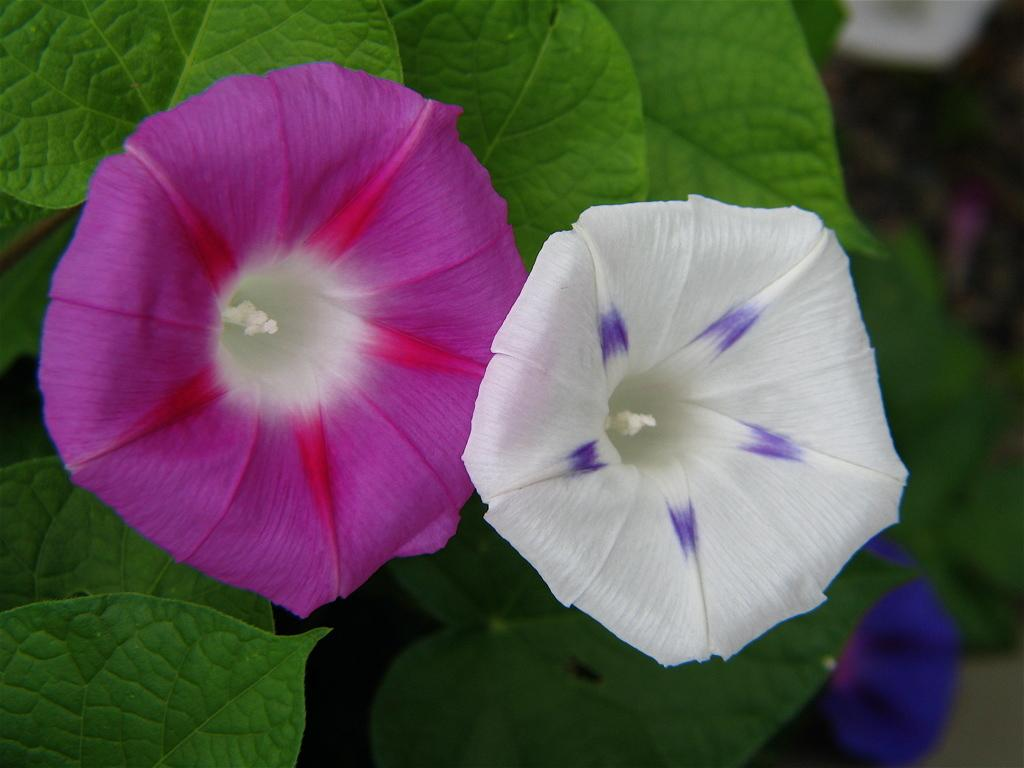How many flowers are present in the image? There are two flowers in the image. What are the colors of the flowers? One flower is violet in color, and the other flower is white in color. What can be found below the flowers? There are green leaves below the flowers. What type of bell can be heard ringing in the image? There is no bell present in the image, and therefore no sound can be heard. 